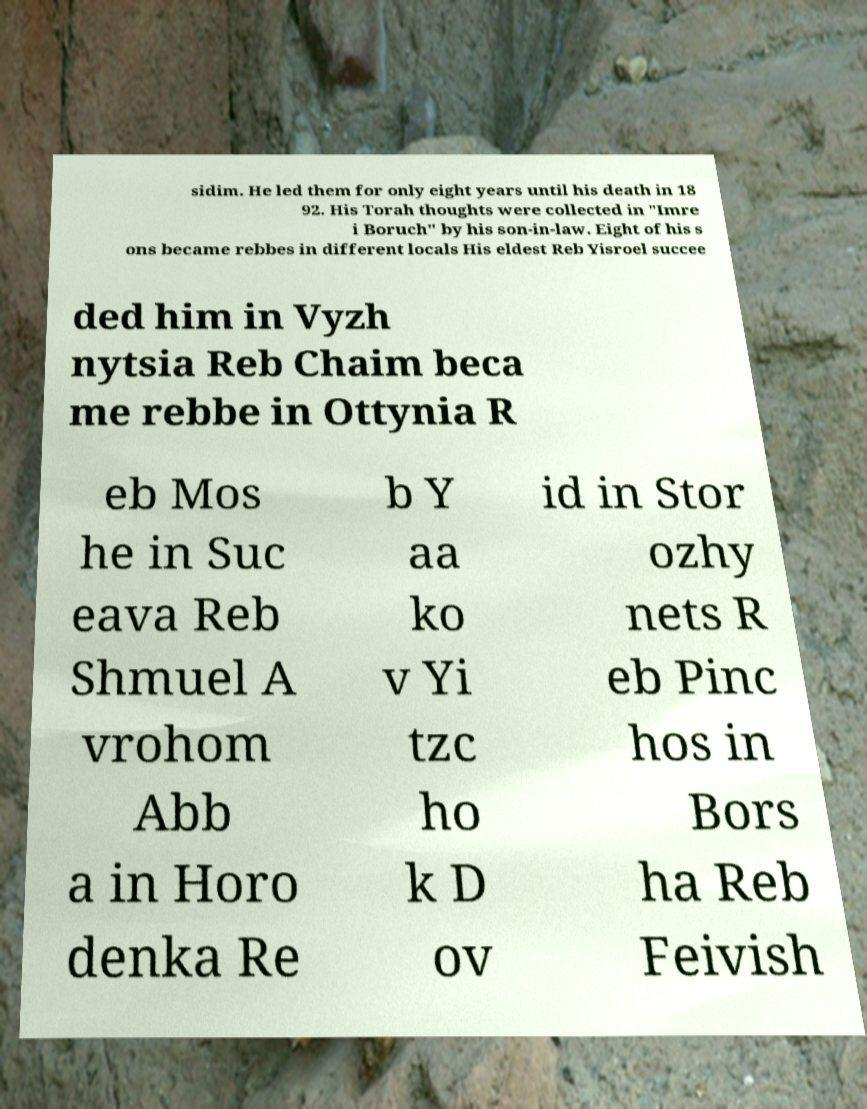What messages or text are displayed in this image? I need them in a readable, typed format. sidim. He led them for only eight years until his death in 18 92. His Torah thoughts were collected in "Imre i Boruch" by his son-in-law. Eight of his s ons became rebbes in different locals His eldest Reb Yisroel succee ded him in Vyzh nytsia Reb Chaim beca me rebbe in Ottynia R eb Mos he in Suc eava Reb Shmuel A vrohom Abb a in Horo denka Re b Y aa ko v Yi tzc ho k D ov id in Stor ozhy nets R eb Pinc hos in Bors ha Reb Feivish 